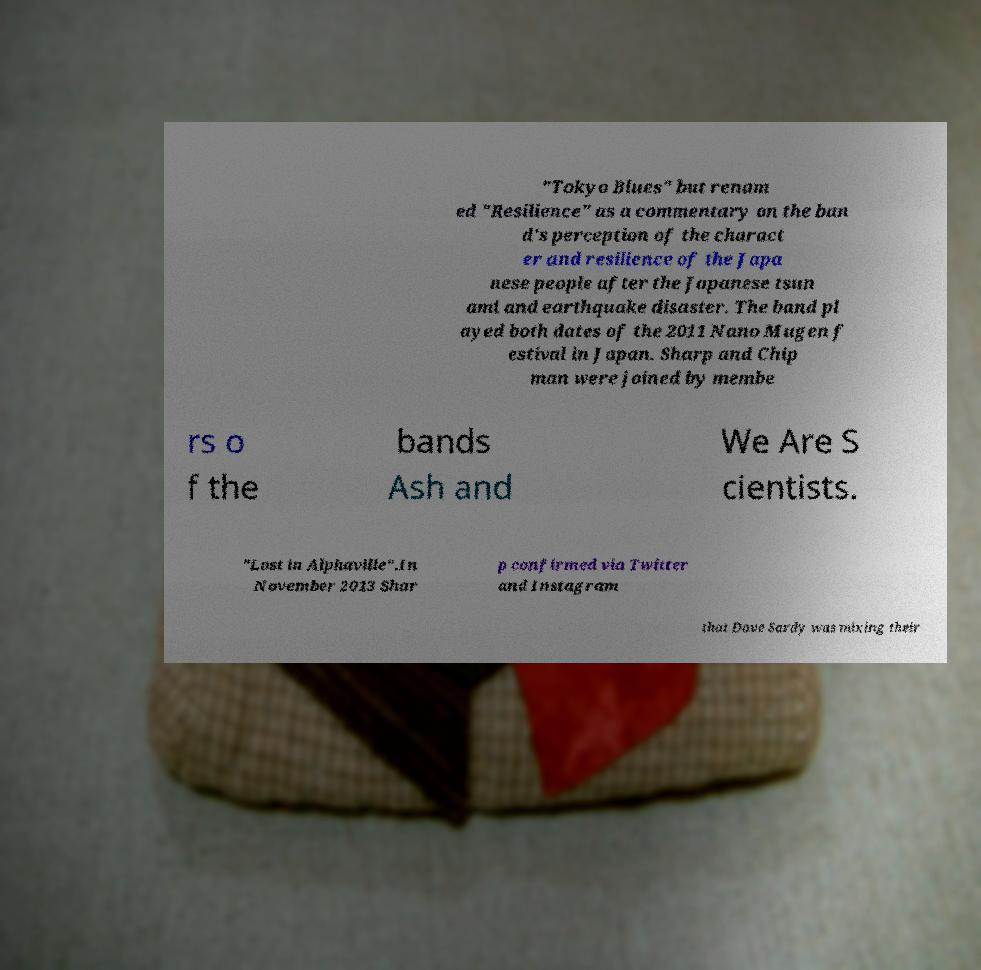Can you read and provide the text displayed in the image?This photo seems to have some interesting text. Can you extract and type it out for me? "Tokyo Blues" but renam ed "Resilience" as a commentary on the ban d's perception of the charact er and resilience of the Japa nese people after the Japanese tsun ami and earthquake disaster. The band pl ayed both dates of the 2011 Nano Mugen f estival in Japan. Sharp and Chip man were joined by membe rs o f the bands Ash and We Are S cientists. "Lost in Alphaville".In November 2013 Shar p confirmed via Twitter and Instagram that Dave Sardy was mixing their 